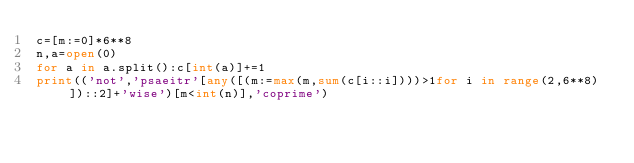Convert code to text. <code><loc_0><loc_0><loc_500><loc_500><_Python_>c=[m:=0]*6**8
n,a=open(0)
for a in a.split():c[int(a)]+=1
print(('not','psaeitr'[any([(m:=max(m,sum(c[i::i])))>1for i in range(2,6**8)])::2]+'wise')[m<int(n)],'coprime')</code> 